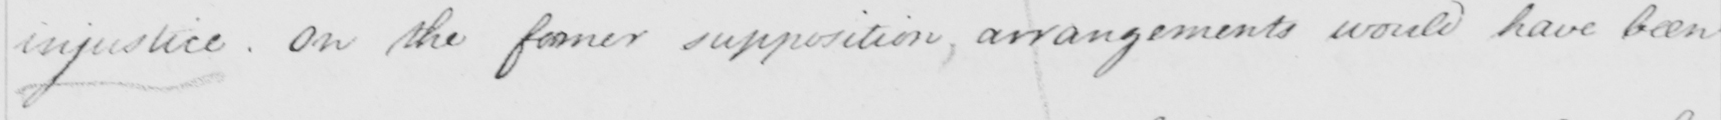Please transcribe the handwritten text in this image. injustice. On the former supposition, arrangements would have been 